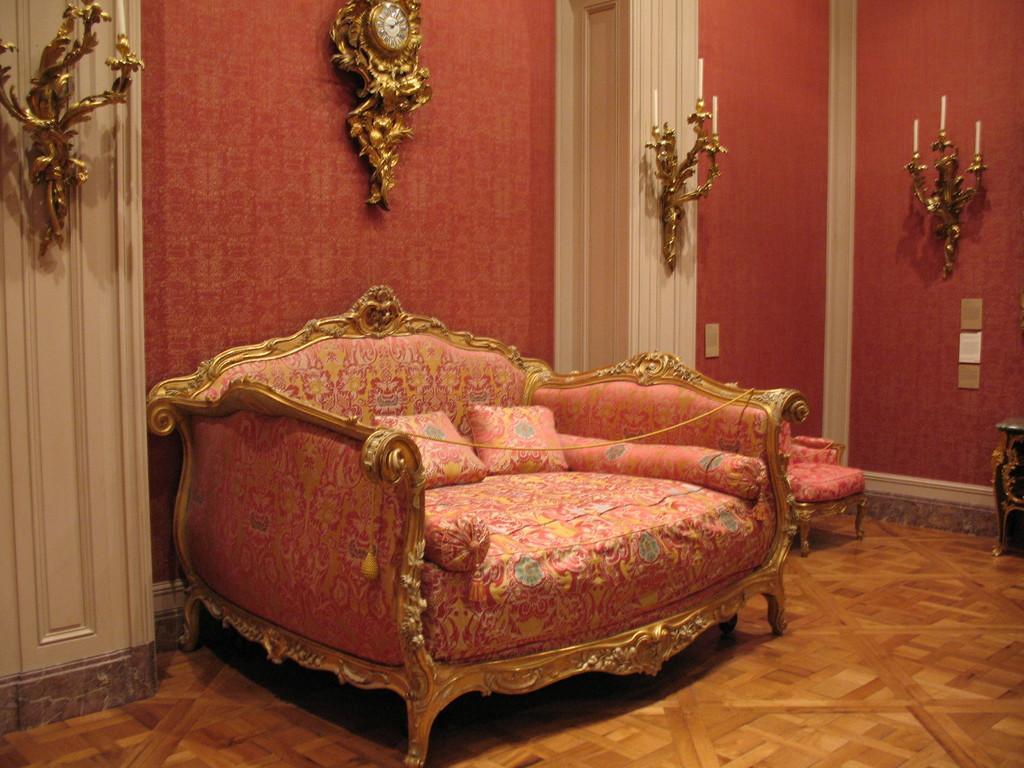Can you describe this image briefly? This is sofa and there are pillows. On the background there is a wall and this is door. There is a chair and this is floor. 